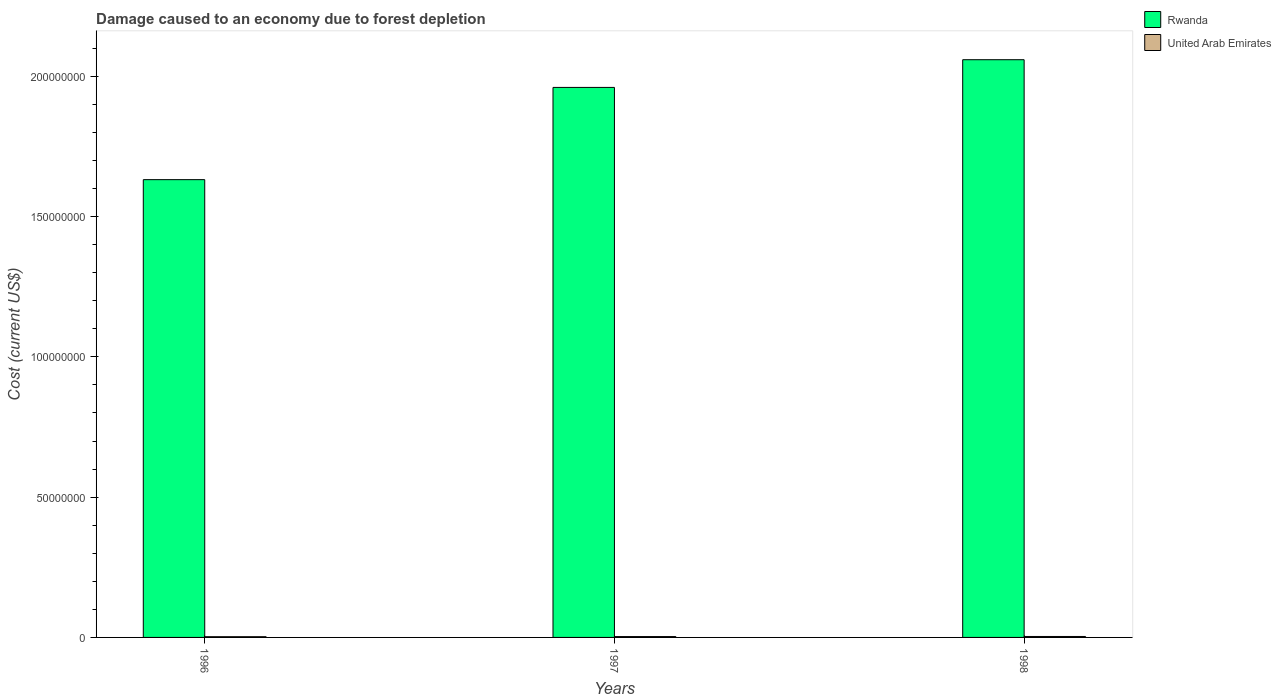How many different coloured bars are there?
Your answer should be very brief. 2. How many groups of bars are there?
Provide a succinct answer. 3. Are the number of bars per tick equal to the number of legend labels?
Your answer should be compact. Yes. Are the number of bars on each tick of the X-axis equal?
Give a very brief answer. Yes. How many bars are there on the 1st tick from the left?
Keep it short and to the point. 2. How many bars are there on the 2nd tick from the right?
Ensure brevity in your answer.  2. What is the cost of damage caused due to forest depletion in Rwanda in 1998?
Your answer should be very brief. 2.06e+08. Across all years, what is the maximum cost of damage caused due to forest depletion in Rwanda?
Your response must be concise. 2.06e+08. Across all years, what is the minimum cost of damage caused due to forest depletion in United Arab Emirates?
Your answer should be compact. 2.59e+05. In which year was the cost of damage caused due to forest depletion in Rwanda maximum?
Your answer should be compact. 1998. In which year was the cost of damage caused due to forest depletion in Rwanda minimum?
Make the answer very short. 1996. What is the total cost of damage caused due to forest depletion in United Arab Emirates in the graph?
Make the answer very short. 9.00e+05. What is the difference between the cost of damage caused due to forest depletion in United Arab Emirates in 1996 and that in 1997?
Offer a very short reply. -4.52e+04. What is the difference between the cost of damage caused due to forest depletion in Rwanda in 1998 and the cost of damage caused due to forest depletion in United Arab Emirates in 1997?
Your response must be concise. 2.06e+08. What is the average cost of damage caused due to forest depletion in United Arab Emirates per year?
Give a very brief answer. 3.00e+05. In the year 1996, what is the difference between the cost of damage caused due to forest depletion in United Arab Emirates and cost of damage caused due to forest depletion in Rwanda?
Offer a very short reply. -1.63e+08. What is the ratio of the cost of damage caused due to forest depletion in United Arab Emirates in 1996 to that in 1998?
Offer a terse response. 0.77. Is the cost of damage caused due to forest depletion in United Arab Emirates in 1997 less than that in 1998?
Your response must be concise. Yes. What is the difference between the highest and the second highest cost of damage caused due to forest depletion in United Arab Emirates?
Provide a succinct answer. 3.18e+04. What is the difference between the highest and the lowest cost of damage caused due to forest depletion in Rwanda?
Ensure brevity in your answer.  4.28e+07. In how many years, is the cost of damage caused due to forest depletion in United Arab Emirates greater than the average cost of damage caused due to forest depletion in United Arab Emirates taken over all years?
Keep it short and to the point. 2. What does the 1st bar from the left in 1997 represents?
Provide a succinct answer. Rwanda. What does the 2nd bar from the right in 1996 represents?
Ensure brevity in your answer.  Rwanda. How many years are there in the graph?
Your answer should be very brief. 3. What is the difference between two consecutive major ticks on the Y-axis?
Ensure brevity in your answer.  5.00e+07. Are the values on the major ticks of Y-axis written in scientific E-notation?
Provide a succinct answer. No. Does the graph contain any zero values?
Give a very brief answer. No. How many legend labels are there?
Your answer should be very brief. 2. How are the legend labels stacked?
Your answer should be very brief. Vertical. What is the title of the graph?
Keep it short and to the point. Damage caused to an economy due to forest depletion. Does "Japan" appear as one of the legend labels in the graph?
Your answer should be compact. No. What is the label or title of the Y-axis?
Offer a very short reply. Cost (current US$). What is the Cost (current US$) in Rwanda in 1996?
Ensure brevity in your answer.  1.63e+08. What is the Cost (current US$) in United Arab Emirates in 1996?
Your answer should be very brief. 2.59e+05. What is the Cost (current US$) of Rwanda in 1997?
Provide a succinct answer. 1.96e+08. What is the Cost (current US$) of United Arab Emirates in 1997?
Offer a very short reply. 3.04e+05. What is the Cost (current US$) of Rwanda in 1998?
Your answer should be very brief. 2.06e+08. What is the Cost (current US$) of United Arab Emirates in 1998?
Provide a succinct answer. 3.36e+05. Across all years, what is the maximum Cost (current US$) in Rwanda?
Offer a very short reply. 2.06e+08. Across all years, what is the maximum Cost (current US$) in United Arab Emirates?
Ensure brevity in your answer.  3.36e+05. Across all years, what is the minimum Cost (current US$) in Rwanda?
Make the answer very short. 1.63e+08. Across all years, what is the minimum Cost (current US$) of United Arab Emirates?
Your answer should be very brief. 2.59e+05. What is the total Cost (current US$) in Rwanda in the graph?
Give a very brief answer. 5.65e+08. What is the total Cost (current US$) of United Arab Emirates in the graph?
Offer a terse response. 9.00e+05. What is the difference between the Cost (current US$) in Rwanda in 1996 and that in 1997?
Offer a very short reply. -3.29e+07. What is the difference between the Cost (current US$) of United Arab Emirates in 1996 and that in 1997?
Your answer should be very brief. -4.52e+04. What is the difference between the Cost (current US$) in Rwanda in 1996 and that in 1998?
Your answer should be compact. -4.28e+07. What is the difference between the Cost (current US$) in United Arab Emirates in 1996 and that in 1998?
Your answer should be compact. -7.69e+04. What is the difference between the Cost (current US$) in Rwanda in 1997 and that in 1998?
Provide a succinct answer. -9.87e+06. What is the difference between the Cost (current US$) in United Arab Emirates in 1997 and that in 1998?
Provide a short and direct response. -3.18e+04. What is the difference between the Cost (current US$) of Rwanda in 1996 and the Cost (current US$) of United Arab Emirates in 1997?
Your response must be concise. 1.63e+08. What is the difference between the Cost (current US$) in Rwanda in 1996 and the Cost (current US$) in United Arab Emirates in 1998?
Give a very brief answer. 1.63e+08. What is the difference between the Cost (current US$) of Rwanda in 1997 and the Cost (current US$) of United Arab Emirates in 1998?
Offer a terse response. 1.96e+08. What is the average Cost (current US$) of Rwanda per year?
Provide a short and direct response. 1.88e+08. What is the average Cost (current US$) of United Arab Emirates per year?
Make the answer very short. 3.00e+05. In the year 1996, what is the difference between the Cost (current US$) in Rwanda and Cost (current US$) in United Arab Emirates?
Provide a short and direct response. 1.63e+08. In the year 1997, what is the difference between the Cost (current US$) of Rwanda and Cost (current US$) of United Arab Emirates?
Offer a terse response. 1.96e+08. In the year 1998, what is the difference between the Cost (current US$) in Rwanda and Cost (current US$) in United Arab Emirates?
Provide a succinct answer. 2.06e+08. What is the ratio of the Cost (current US$) of Rwanda in 1996 to that in 1997?
Your response must be concise. 0.83. What is the ratio of the Cost (current US$) in United Arab Emirates in 1996 to that in 1997?
Offer a very short reply. 0.85. What is the ratio of the Cost (current US$) of Rwanda in 1996 to that in 1998?
Offer a terse response. 0.79. What is the ratio of the Cost (current US$) in United Arab Emirates in 1996 to that in 1998?
Give a very brief answer. 0.77. What is the ratio of the Cost (current US$) of Rwanda in 1997 to that in 1998?
Keep it short and to the point. 0.95. What is the ratio of the Cost (current US$) in United Arab Emirates in 1997 to that in 1998?
Make the answer very short. 0.91. What is the difference between the highest and the second highest Cost (current US$) in Rwanda?
Your response must be concise. 9.87e+06. What is the difference between the highest and the second highest Cost (current US$) of United Arab Emirates?
Keep it short and to the point. 3.18e+04. What is the difference between the highest and the lowest Cost (current US$) of Rwanda?
Your response must be concise. 4.28e+07. What is the difference between the highest and the lowest Cost (current US$) in United Arab Emirates?
Ensure brevity in your answer.  7.69e+04. 